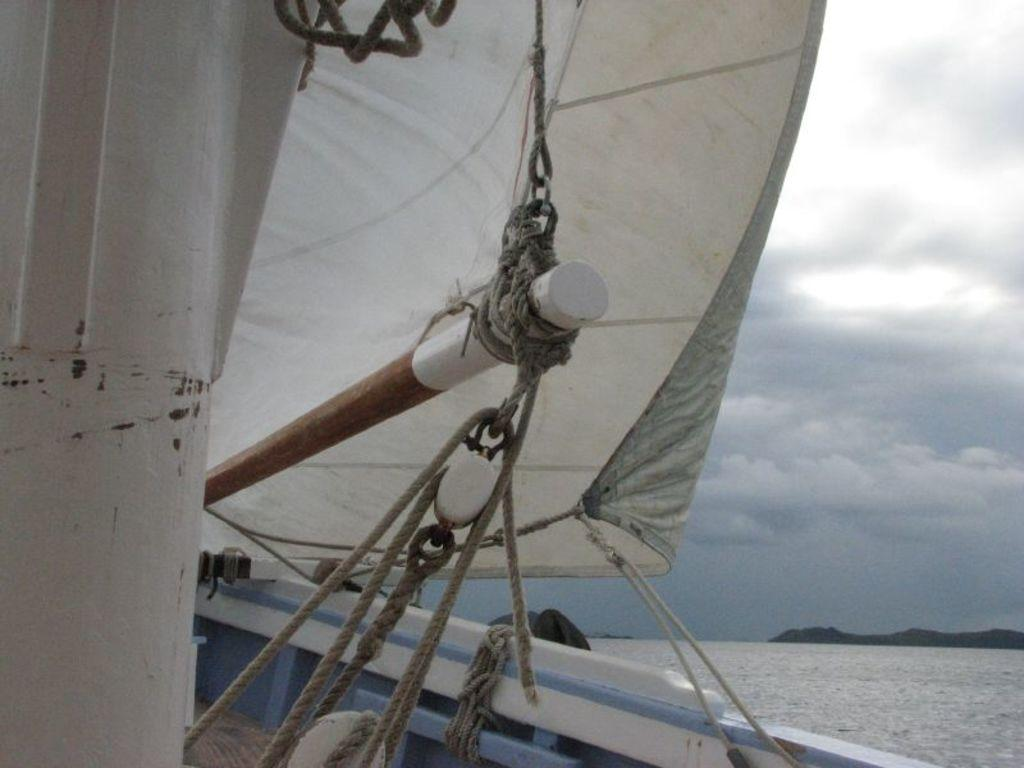What is located on the left side of the image? There is a boat on the left side of the image. What can be seen in the image besides the boat? There are cables, cloth, hills, water, and the sky visible in the image. What is the terrain like on the right side of the image? There are hills on the right side of the image. What is the condition of the water in the image? The water is visible in the image. What is visible in the sky in the image? The sky is visible in the image, and there are clouds present. What type of stamp can be seen on the boat in the image? There is no stamp present in the image. 